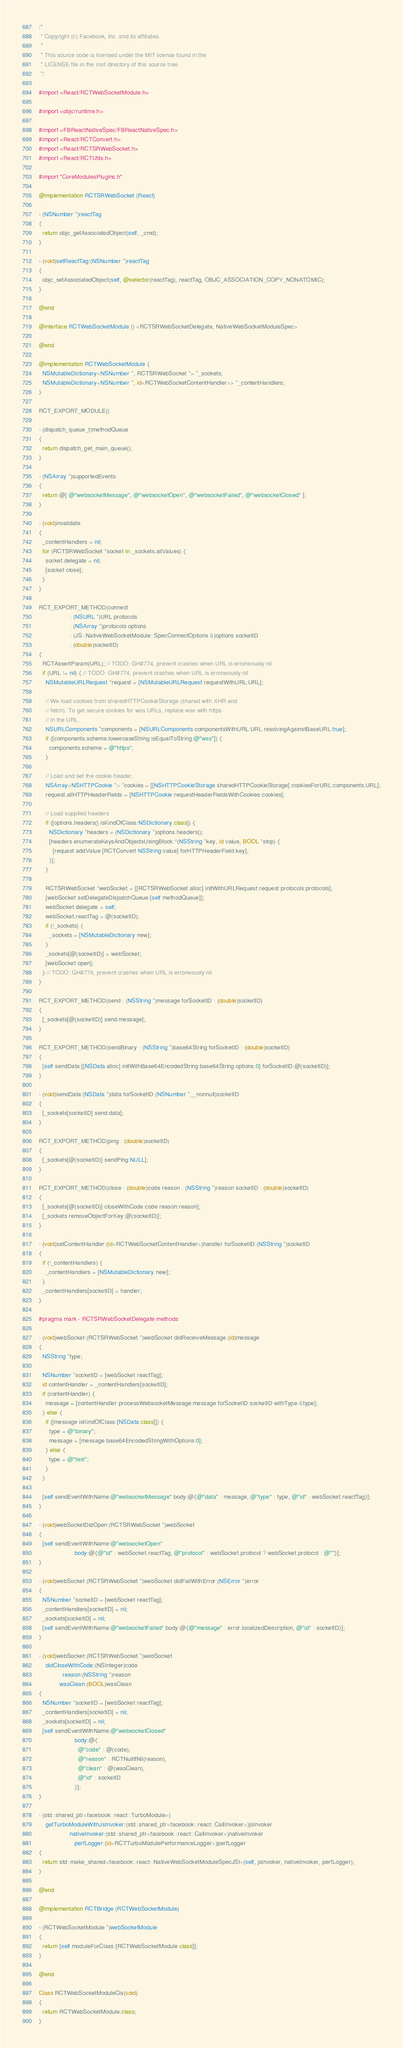Convert code to text. <code><loc_0><loc_0><loc_500><loc_500><_ObjectiveC_>/*
 * Copyright (c) Facebook, Inc. and its affiliates.
 *
 * This source code is licensed under the MIT license found in the
 * LICENSE file in the root directory of this source tree.
 */

#import <React/RCTWebSocketModule.h>

#import <objc/runtime.h>

#import <FBReactNativeSpec/FBReactNativeSpec.h>
#import <React/RCTConvert.h>
#import <React/RCTSRWebSocket.h>
#import <React/RCTUtils.h>

#import "CoreModulesPlugins.h"

@implementation RCTSRWebSocket (React)

- (NSNumber *)reactTag
{
  return objc_getAssociatedObject(self, _cmd);
}

- (void)setReactTag:(NSNumber *)reactTag
{
  objc_setAssociatedObject(self, @selector(reactTag), reactTag, OBJC_ASSOCIATION_COPY_NONATOMIC);
}

@end

@interface RCTWebSocketModule () <RCTSRWebSocketDelegate, NativeWebSocketModuleSpec>

@end

@implementation RCTWebSocketModule {
  NSMutableDictionary<NSNumber *, RCTSRWebSocket *> *_sockets;
  NSMutableDictionary<NSNumber *, id<RCTWebSocketContentHandler>> *_contentHandlers;
}

RCT_EXPORT_MODULE()

- (dispatch_queue_t)methodQueue
{
  return dispatch_get_main_queue();
}

- (NSArray *)supportedEvents
{
  return @[ @"websocketMessage", @"websocketOpen", @"websocketFailed", @"websocketClosed" ];
}

- (void)invalidate
{
  _contentHandlers = nil;
  for (RCTSRWebSocket *socket in _sockets.allValues) {
    socket.delegate = nil;
    [socket close];
  }
}

RCT_EXPORT_METHOD(connect
                  : (NSURL *)URL protocols
                  : (NSArray *)protocols options
                  : (JS::NativeWebSocketModule::SpecConnectOptions &)options socketID
                  : (double)socketID)
{
  RCTAssertParam(URL); // TODO: GH#774, prevent crashes when URL is erroneously nil
  if (URL != nil) { // TODO: GH#774, prevent crashes when URL is erroneously nil
    NSMutableURLRequest *request = [NSMutableURLRequest requestWithURL:URL];

    // We load cookies from sharedHTTPCookieStorage (shared with XHR and
    // fetch). To get secure cookies for wss URLs, replace wss with https
    // in the URL.
    NSURLComponents *components = [NSURLComponents componentsWithURL:URL resolvingAgainstBaseURL:true];
    if ([components.scheme.lowercaseString isEqualToString:@"wss"]) {
      components.scheme = @"https";
    }

    // Load and set the cookie header.
    NSArray<NSHTTPCookie *> *cookies = [[NSHTTPCookieStorage sharedHTTPCookieStorage] cookiesForURL:components.URL];
    request.allHTTPHeaderFields = [NSHTTPCookie requestHeaderFieldsWithCookies:cookies];

    // Load supplied headers
    if ([options.headers() isKindOfClass:NSDictionary.class]) {
      NSDictionary *headers = (NSDictionary *)options.headers();
      [headers enumerateKeysAndObjectsUsingBlock:^(NSString *key, id value, BOOL *stop) {
        [request addValue:[RCTConvert NSString:value] forHTTPHeaderField:key];
      }];
    }

    RCTSRWebSocket *webSocket = [[RCTSRWebSocket alloc] initWithURLRequest:request protocols:protocols];
    [webSocket setDelegateDispatchQueue:[self methodQueue]];
    webSocket.delegate = self;
    webSocket.reactTag = @(socketID);
    if (!_sockets) {
      _sockets = [NSMutableDictionary new];
    }
    _sockets[@(socketID)] = webSocket;
    [webSocket open];
  } // TODO: GH#774, prevent crashes when URL is erroneously nil
}

RCT_EXPORT_METHOD(send : (NSString *)message forSocketID : (double)socketID)
{
  [_sockets[@(socketID)] send:message];
}

RCT_EXPORT_METHOD(sendBinary : (NSString *)base64String forSocketID : (double)socketID)
{
  [self sendData:[[NSData alloc] initWithBase64EncodedString:base64String options:0] forSocketID:@(socketID)];
}

- (void)sendData:(NSData *)data forSocketID:(NSNumber *__nonnull)socketID
{
  [_sockets[socketID] send:data];
}

RCT_EXPORT_METHOD(ping : (double)socketID)
{
  [_sockets[@(socketID)] sendPing:NULL];
}

RCT_EXPORT_METHOD(close : (double)code reason : (NSString *)reason socketID : (double)socketID)
{
  [_sockets[@(socketID)] closeWithCode:code reason:reason];
  [_sockets removeObjectForKey:@(socketID)];
}

- (void)setContentHandler:(id<RCTWebSocketContentHandler>)handler forSocketID:(NSString *)socketID
{
  if (!_contentHandlers) {
    _contentHandlers = [NSMutableDictionary new];
  }
  _contentHandlers[socketID] = handler;
}

#pragma mark - RCTSRWebSocketDelegate methods

- (void)webSocket:(RCTSRWebSocket *)webSocket didReceiveMessage:(id)message
{
  NSString *type;

  NSNumber *socketID = [webSocket reactTag];
  id contentHandler = _contentHandlers[socketID];
  if (contentHandler) {
    message = [contentHandler processWebsocketMessage:message forSocketID:socketID withType:&type];
  } else {
    if ([message isKindOfClass:[NSData class]]) {
      type = @"binary";
      message = [message base64EncodedStringWithOptions:0];
    } else {
      type = @"text";
    }
  }

  [self sendEventWithName:@"websocketMessage" body:@{@"data" : message, @"type" : type, @"id" : webSocket.reactTag}];
}

- (void)webSocketDidOpen:(RCTSRWebSocket *)webSocket
{
  [self sendEventWithName:@"websocketOpen"
                     body:@{@"id" : webSocket.reactTag, @"protocol" : webSocket.protocol ? webSocket.protocol : @""}];
}

- (void)webSocket:(RCTSRWebSocket *)webSocket didFailWithError:(NSError *)error
{
  NSNumber *socketID = [webSocket reactTag];
  _contentHandlers[socketID] = nil;
  _sockets[socketID] = nil;
  [self sendEventWithName:@"websocketFailed" body:@{@"message" : error.localizedDescription, @"id" : socketID}];
}

- (void)webSocket:(RCTSRWebSocket *)webSocket
    didCloseWithCode:(NSInteger)code
              reason:(NSString *)reason
            wasClean:(BOOL)wasClean
{
  NSNumber *socketID = [webSocket reactTag];
  _contentHandlers[socketID] = nil;
  _sockets[socketID] = nil;
  [self sendEventWithName:@"websocketClosed"
                     body:@{
                       @"code" : @(code),
                       @"reason" : RCTNullIfNil(reason),
                       @"clean" : @(wasClean),
                       @"id" : socketID
                     }];
}

- (std::shared_ptr<facebook::react::TurboModule>)
    getTurboModuleWithJsInvoker:(std::shared_ptr<facebook::react::CallInvoker>)jsInvoker
                  nativeInvoker:(std::shared_ptr<facebook::react::CallInvoker>)nativeInvoker
                     perfLogger:(id<RCTTurboModulePerformanceLogger>)perfLogger
{
  return std::make_shared<facebook::react::NativeWebSocketModuleSpecJSI>(self, jsInvoker, nativeInvoker, perfLogger);
}

@end

@implementation RCTBridge (RCTWebSocketModule)

- (RCTWebSocketModule *)webSocketModule
{
  return [self moduleForClass:[RCTWebSocketModule class]];
}

@end

Class RCTWebSocketModuleCls(void)
{
  return RCTWebSocketModule.class;
}
</code> 